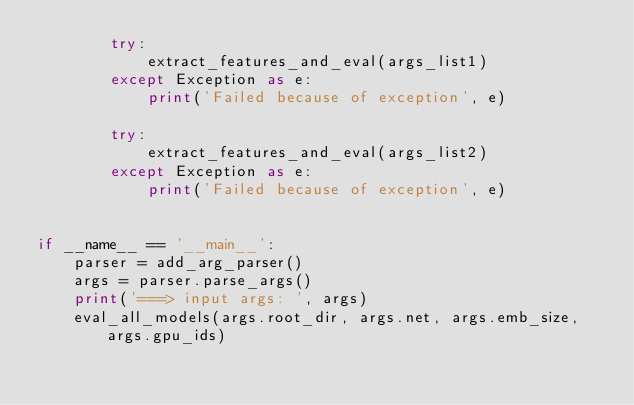Convert code to text. <code><loc_0><loc_0><loc_500><loc_500><_Python_>        try:
            extract_features_and_eval(args_list1)
        except Exception as e:
            print('Failed because of exception', e)

        try:
            extract_features_and_eval(args_list2)
        except Exception as e:
            print('Failed because of exception', e)


if __name__ == '__main__':
    parser = add_arg_parser()
    args = parser.parse_args()
    print('===> input args: ', args)
    eval_all_models(args.root_dir, args.net, args.emb_size, args.gpu_ids)

</code> 